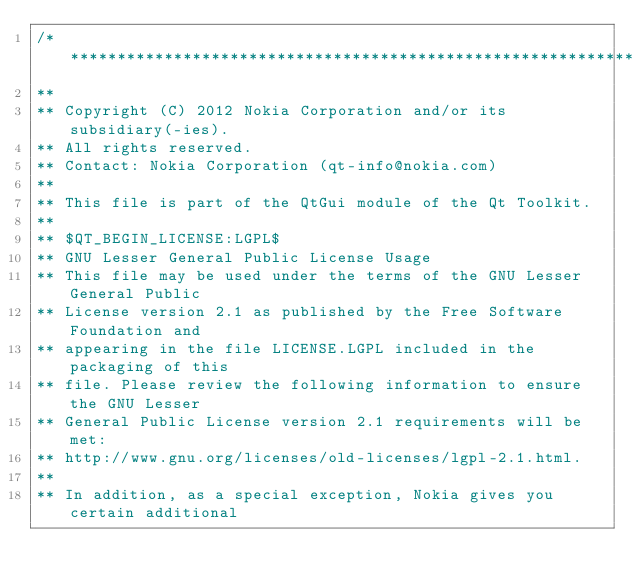<code> <loc_0><loc_0><loc_500><loc_500><_ObjectiveC_>/****************************************************************************
**
** Copyright (C) 2012 Nokia Corporation and/or its subsidiary(-ies).
** All rights reserved.
** Contact: Nokia Corporation (qt-info@nokia.com)
**
** This file is part of the QtGui module of the Qt Toolkit.
**
** $QT_BEGIN_LICENSE:LGPL$
** GNU Lesser General Public License Usage
** This file may be used under the terms of the GNU Lesser General Public
** License version 2.1 as published by the Free Software Foundation and
** appearing in the file LICENSE.LGPL included in the packaging of this
** file. Please review the following information to ensure the GNU Lesser
** General Public License version 2.1 requirements will be met:
** http://www.gnu.org/licenses/old-licenses/lgpl-2.1.html.
**
** In addition, as a special exception, Nokia gives you certain additional</code> 